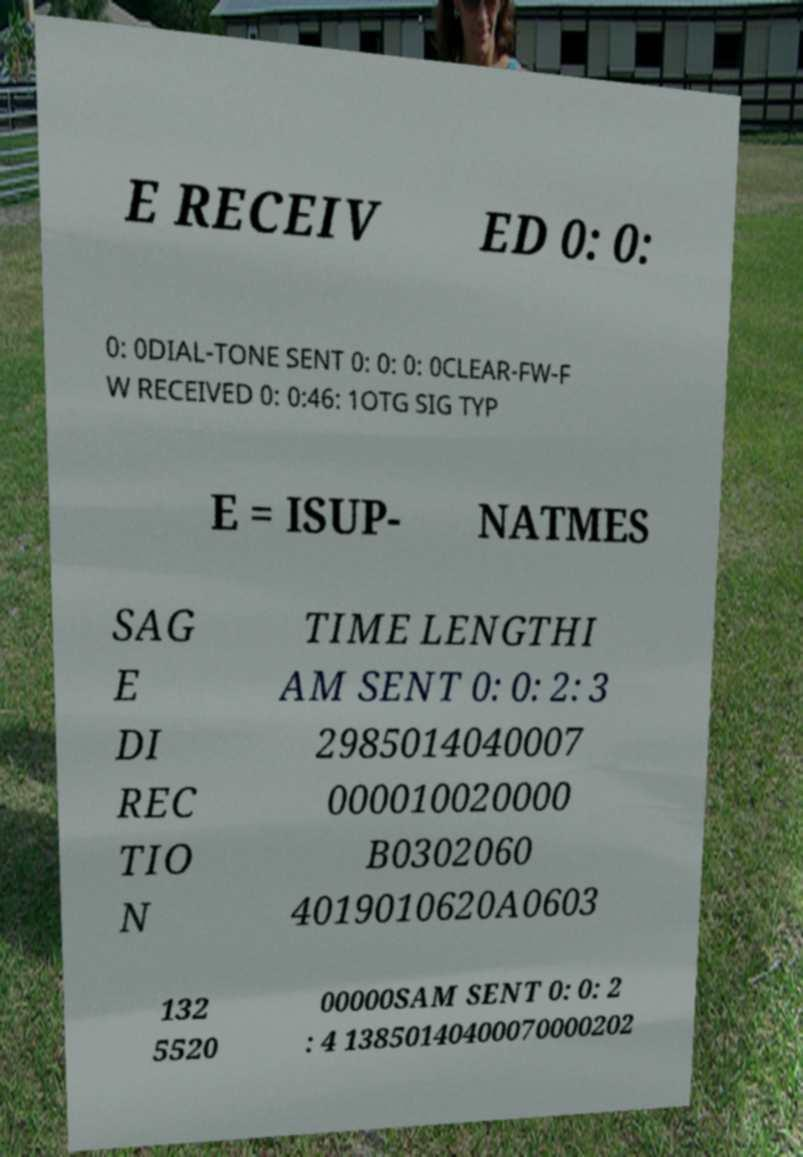What messages or text are displayed in this image? I need them in a readable, typed format. E RECEIV ED 0: 0: 0: 0DIAL-TONE SENT 0: 0: 0: 0CLEAR-FW-F W RECEIVED 0: 0:46: 1OTG SIG TYP E = ISUP- NATMES SAG E DI REC TIO N TIME LENGTHI AM SENT 0: 0: 2: 3 2985014040007 000010020000 B0302060 4019010620A0603 132 5520 00000SAM SENT 0: 0: 2 : 4 13850140400070000202 